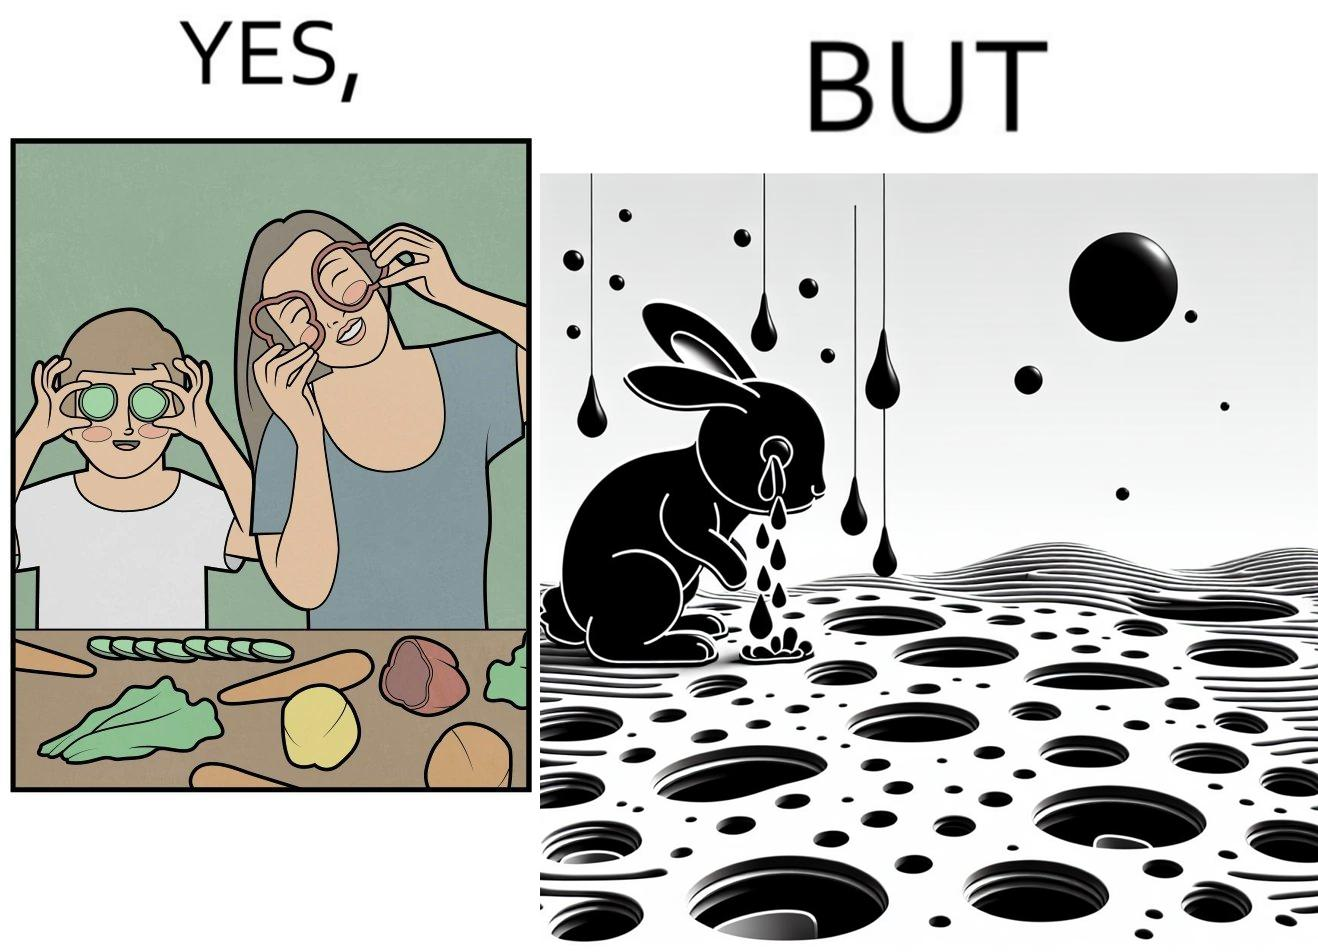Is there satirical content in this image? Yes, this image is satirical. 